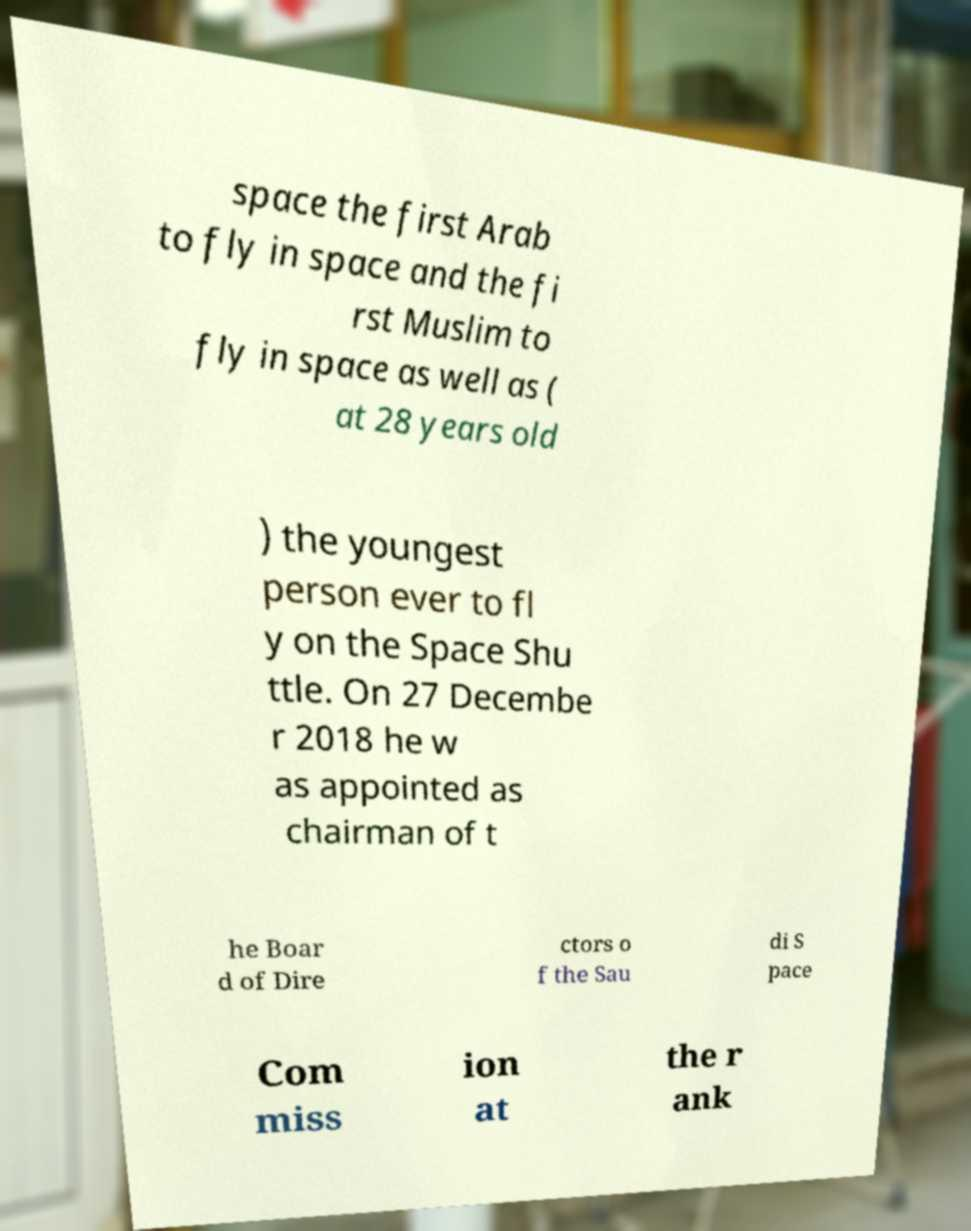I need the written content from this picture converted into text. Can you do that? space the first Arab to fly in space and the fi rst Muslim to fly in space as well as ( at 28 years old ) the youngest person ever to fl y on the Space Shu ttle. On 27 Decembe r 2018 he w as appointed as chairman of t he Boar d of Dire ctors o f the Sau di S pace Com miss ion at the r ank 